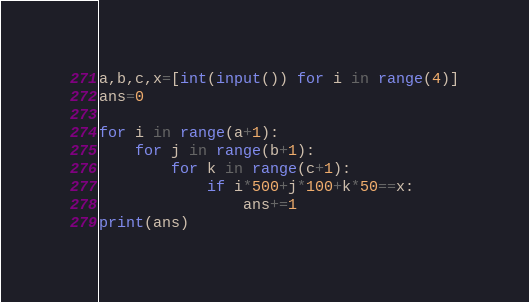Convert code to text. <code><loc_0><loc_0><loc_500><loc_500><_Python_>a,b,c,x=[int(input()) for i in range(4)]
ans=0

for i in range(a+1):
    for j in range(b+1):
        for k in range(c+1):
            if i*500+j*100+k*50==x:
                ans+=1
print(ans)  </code> 